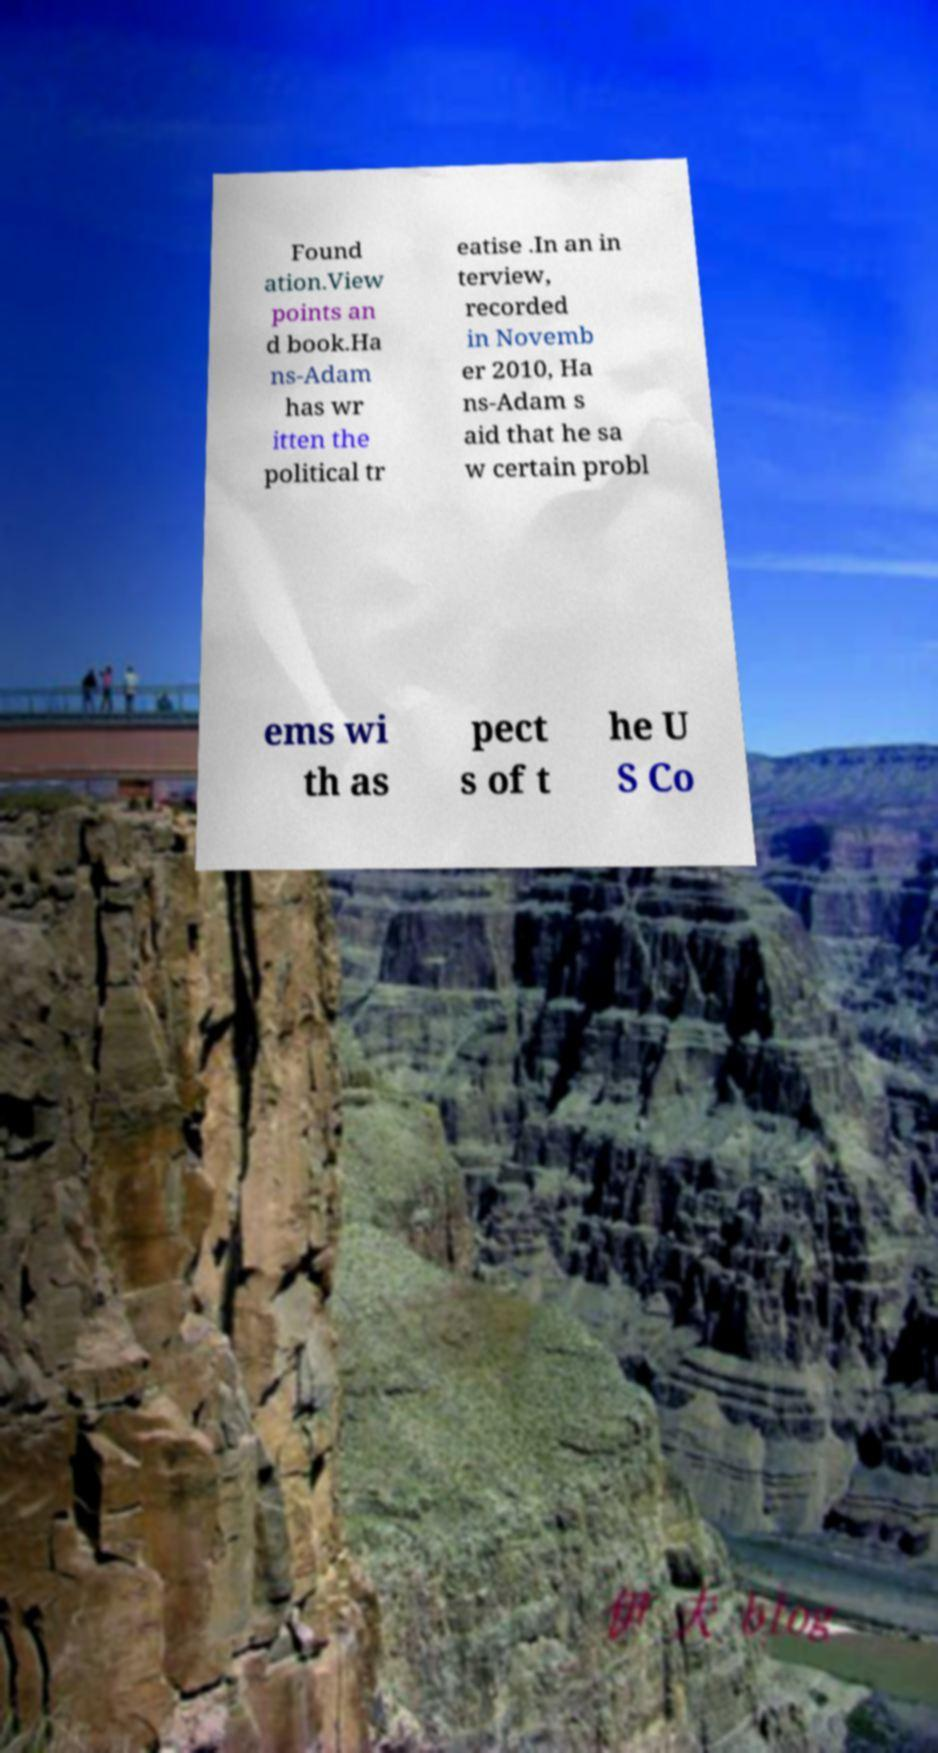Please read and relay the text visible in this image. What does it say? Found ation.View points an d book.Ha ns-Adam has wr itten the political tr eatise .In an in terview, recorded in Novemb er 2010, Ha ns-Adam s aid that he sa w certain probl ems wi th as pect s of t he U S Co 